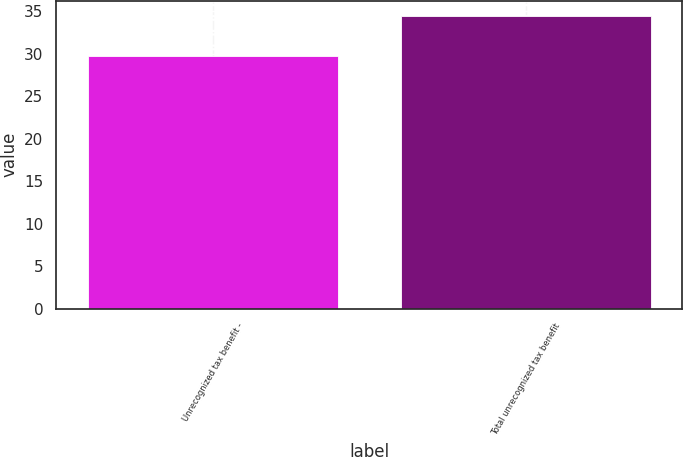Convert chart to OTSL. <chart><loc_0><loc_0><loc_500><loc_500><bar_chart><fcel>Unrecognized tax benefit -<fcel>Total unrecognized tax benefit<nl><fcel>29.8<fcel>34.5<nl></chart> 